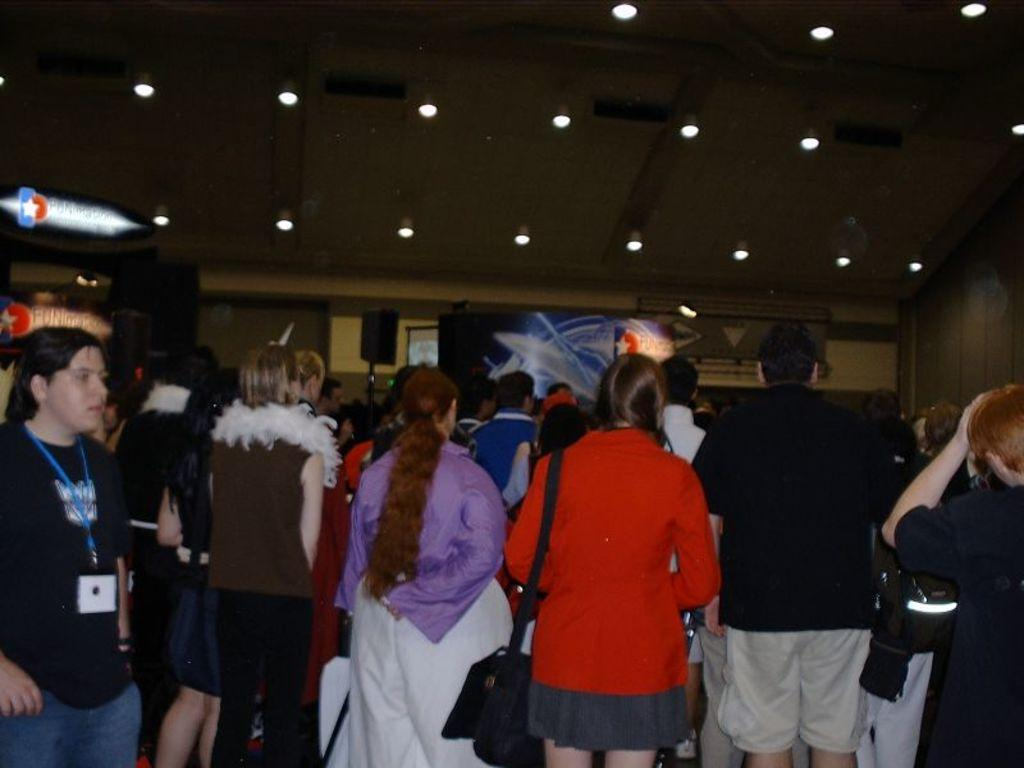What is the main focus of the image? The main focus of the image is the people in the center. What can be seen on the left side of the image? There are posters on the left side of the image. Are there any posters in the center of the image? Yes, there are posters in the center of the image. What is located at the top side of the image? There are lamps at the top side of the image. Can you describe the cave that is present in the image? There is no cave present in the image; it features people, posters, and lamps. What type of lipstick is the person wearing in the image? There is no person wearing lipstick in the image, as the focus is on the people in the center and the surrounding elements. 